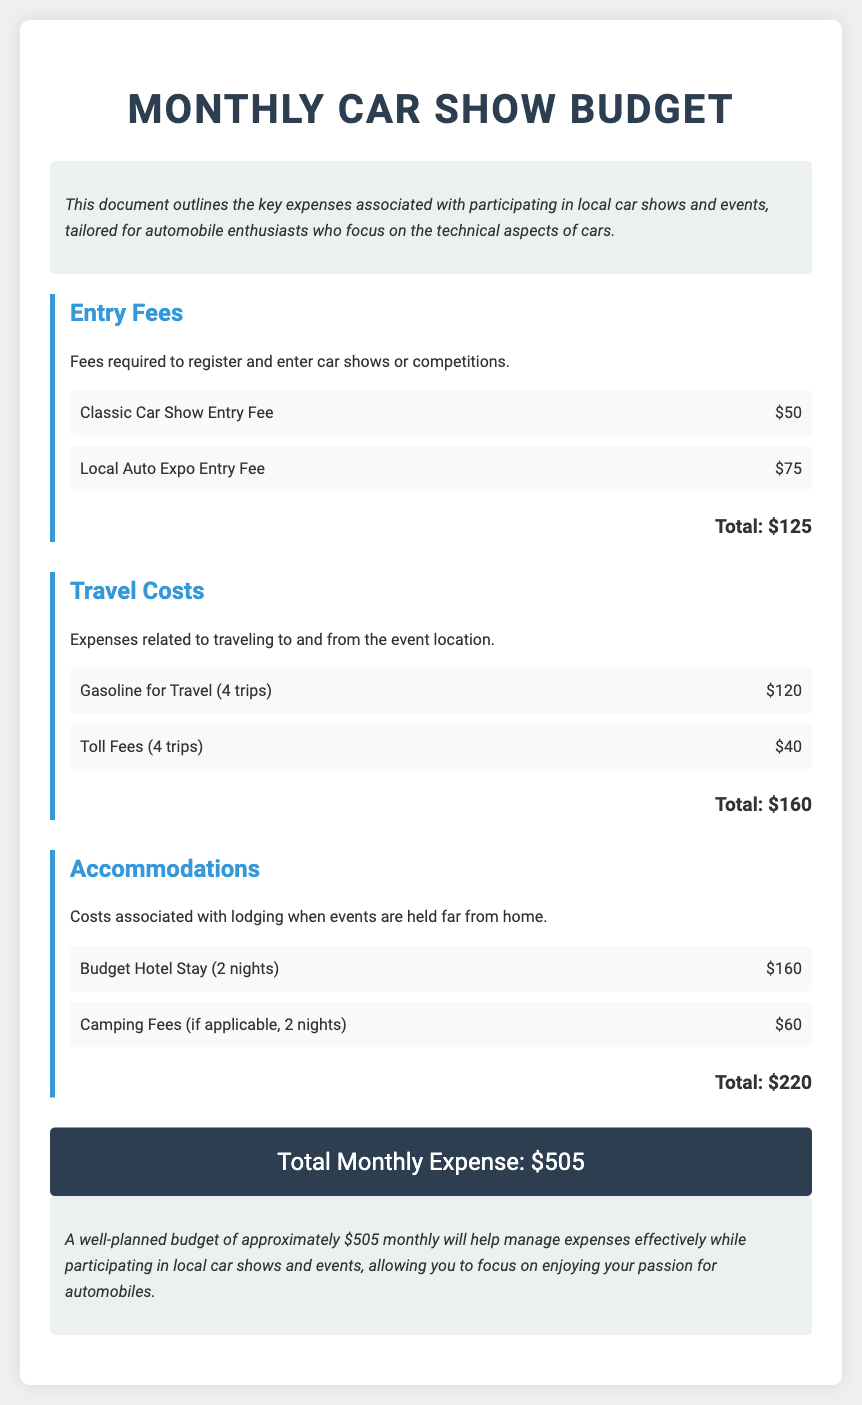What is the total entry fee? The total entry fee is the sum of all entry fees listed in the document, which is $50 + $75 = $125.
Answer: $125 What are the gasoline costs for travel? The document specifies that the gasoline costs for travel are $120 for four trips.
Answer: $120 How many nights is the hotel stay? The budget outlines the hotel stay as being for 2 nights.
Answer: 2 nights What is the overall total monthly expense? The overall total monthly expense is the grand total calculated at the end of the document, which is $505.
Answer: $505 What are the camping fees? The camping fees mentioned for the budget are $60 for two nights if applicable.
Answer: $60 What is the total for travel costs? The total for travel costs is derived from adding gasoline and toll fees, which is $120 + $40 = $160.
Answer: $160 What is the cost of the Classic Car Show Entry Fee? The document specifies the cost of the Classic Car Show Entry Fee as $50.
Answer: $50 What is the total accommodation cost? The total accommodation cost is calculated by adding hotel and camping fees, which is $160 + $60 = $220.
Answer: $220 